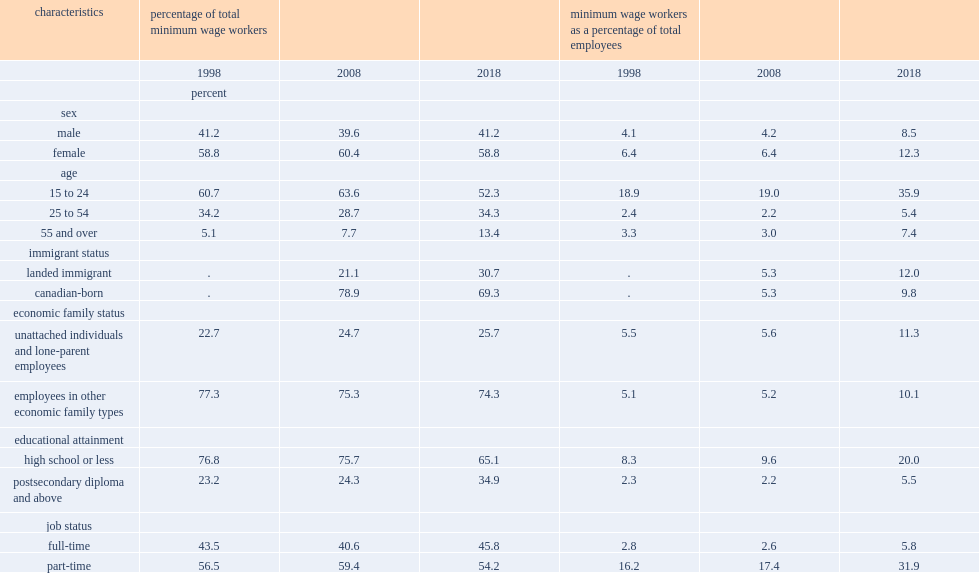In 1998, what was the percentage of minimum wage workers aged 15 to 24? 60.7. What was the percentage of youth minimum-wage workers accounting for? 52.3. In 2018, what was the percentage of immigrant employees earned minimum wage? 12.0. In 2018, what was the percentage of canadian-born employees earned minimum wage? 9.8. In 2018, what was the percentage of unattached individuals and lone-parent employees earned minimum wage? 11.3. In 2018, what was the percentage of other economic family types employees earned minimum wage? 10.1. 